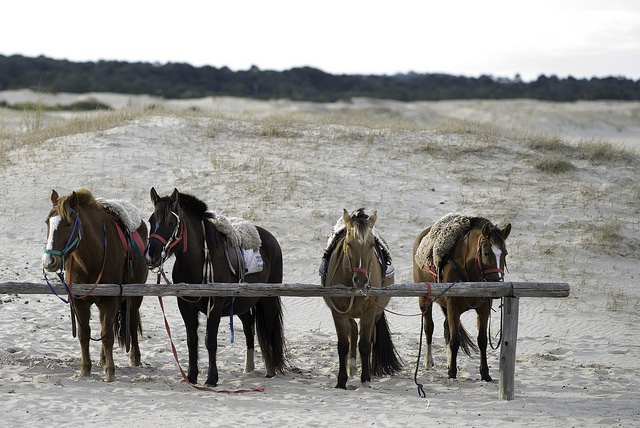Describe the objects in this image and their specific colors. I can see horse in white, black, gray, darkgray, and maroon tones, horse in white, black, maroon, and gray tones, horse in white, black, gray, and darkgray tones, and horse in white, black, and gray tones in this image. 